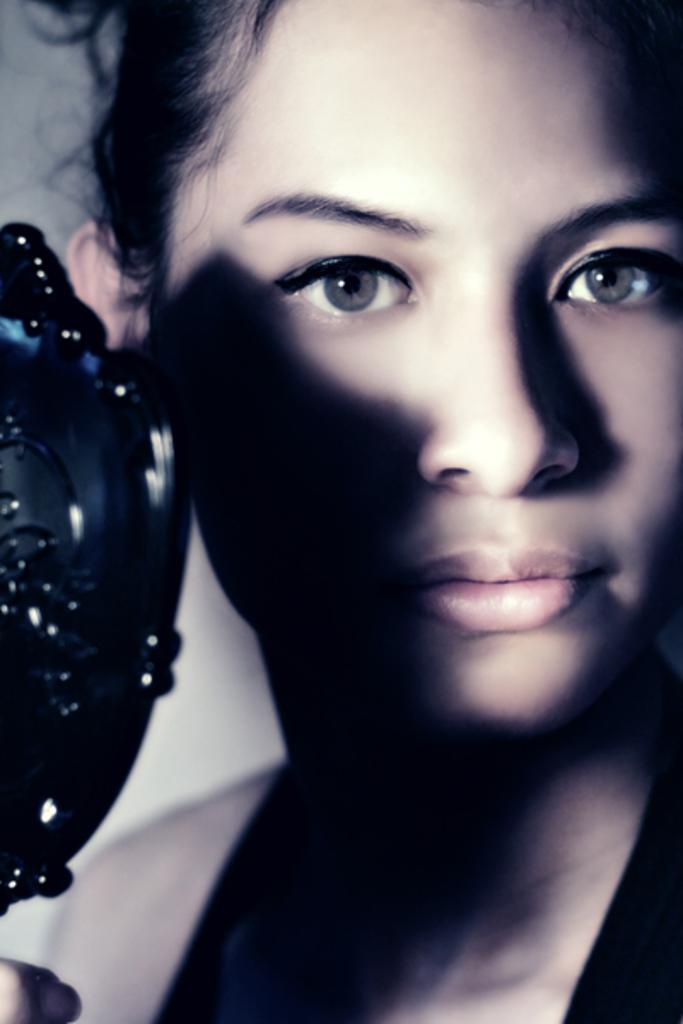What is the main subject of the image? The main subject of the image is a person's face. Can you describe any objects in front of the person's face? Yes, there is a black color object in front of the person's face. How many rabbits can be seen playing near the window in the image? There are no rabbits or windows present in the image. What type of coal is visible in the image? There is no coal present in the image. 